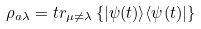<formula> <loc_0><loc_0><loc_500><loc_500>\rho _ { a \lambda } = t r _ { \mu \neq \lambda } \left \{ | \psi ( t ) \rangle \langle \psi ( t ) | \right \}</formula> 